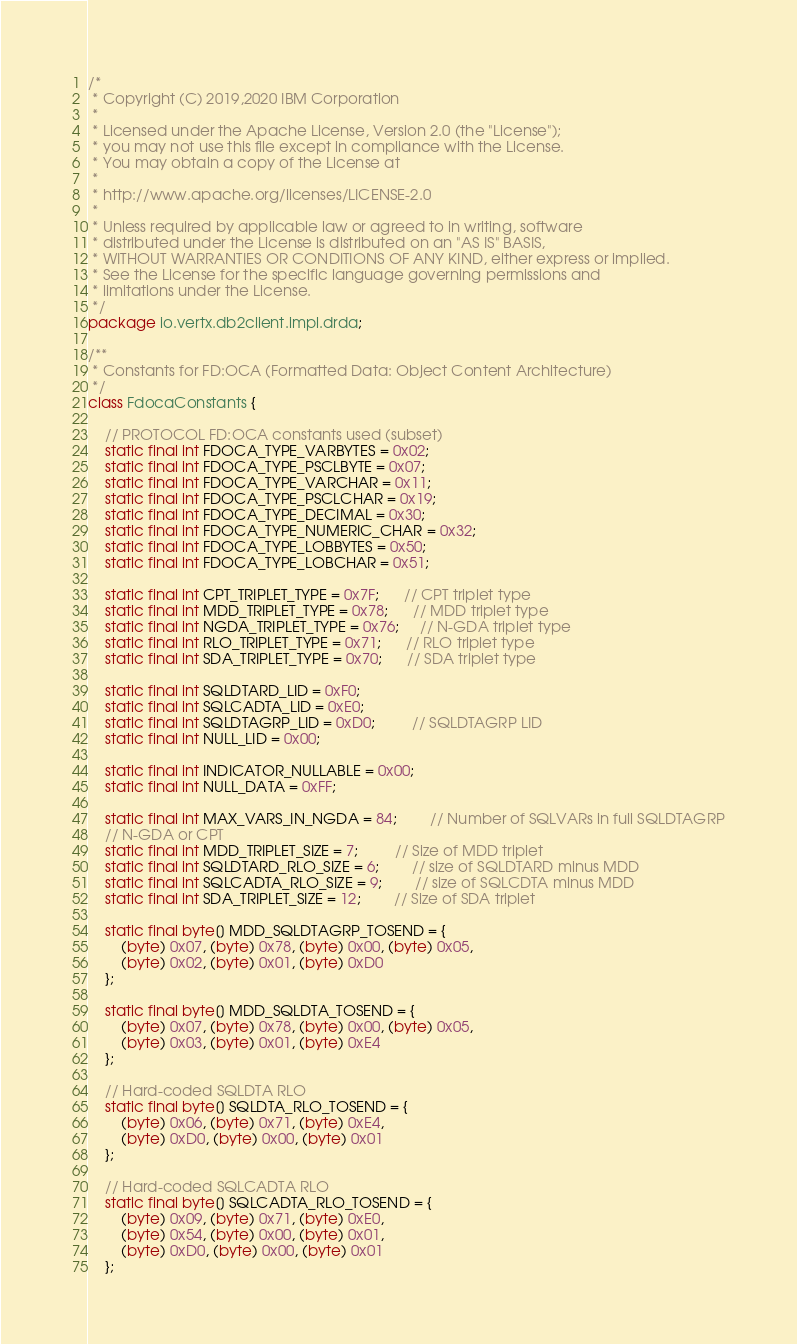<code> <loc_0><loc_0><loc_500><loc_500><_Java_>/*
 * Copyright (C) 2019,2020 IBM Corporation
 *
 * Licensed under the Apache License, Version 2.0 (the "License");
 * you may not use this file except in compliance with the License.
 * You may obtain a copy of the License at
 *
 * http://www.apache.org/licenses/LICENSE-2.0
 *
 * Unless required by applicable law or agreed to in writing, software
 * distributed under the License is distributed on an "AS IS" BASIS,
 * WITHOUT WARRANTIES OR CONDITIONS OF ANY KIND, either express or implied.
 * See the License for the specific language governing permissions and
 * limitations under the License.
 */
package io.vertx.db2client.impl.drda;

/**
 * Constants for FD:OCA (Formatted Data: Object Content Architecture) 
 */
class FdocaConstants {

    // PROTOCOL FD:OCA constants used (subset)
    static final int FDOCA_TYPE_VARBYTES = 0x02;
    static final int FDOCA_TYPE_PSCLBYTE = 0x07;
    static final int FDOCA_TYPE_VARCHAR = 0x11;
    static final int FDOCA_TYPE_PSCLCHAR = 0x19;
    static final int FDOCA_TYPE_DECIMAL = 0x30;
    static final int FDOCA_TYPE_NUMERIC_CHAR = 0x32;
    static final int FDOCA_TYPE_LOBBYTES = 0x50;
    static final int FDOCA_TYPE_LOBCHAR = 0x51;

    static final int CPT_TRIPLET_TYPE = 0x7F;      // CPT triplet type
    static final int MDD_TRIPLET_TYPE = 0x78;      // MDD triplet type
    static final int NGDA_TRIPLET_TYPE = 0x76;     // N-GDA triplet type
    static final int RLO_TRIPLET_TYPE = 0x71;      // RLO triplet type
    static final int SDA_TRIPLET_TYPE = 0x70;      // SDA triplet type

    static final int SQLDTARD_LID = 0xF0;
    static final int SQLCADTA_LID = 0xE0;
    static final int SQLDTAGRP_LID = 0xD0;         // SQLDTAGRP LID
    static final int NULL_LID = 0x00;

    static final int INDICATOR_NULLABLE = 0x00;
    static final int NULL_DATA = 0xFF;

    static final int MAX_VARS_IN_NGDA = 84;        // Number of SQLVARs in full SQLDTAGRP
    // N-GDA or CPT
    static final int MDD_TRIPLET_SIZE = 7;         // Size of MDD triplet
    static final int SQLDTARD_RLO_SIZE = 6;        // size of SQLDTARD minus MDD
    static final int SQLCADTA_RLO_SIZE = 9;        // size of SQLCDTA minus MDD
    static final int SDA_TRIPLET_SIZE = 12;        // Size of SDA triplet

    static final byte[] MDD_SQLDTAGRP_TOSEND = {
        (byte) 0x07, (byte) 0x78, (byte) 0x00, (byte) 0x05,
        (byte) 0x02, (byte) 0x01, (byte) 0xD0
    };

    static final byte[] MDD_SQLDTA_TOSEND = {
        (byte) 0x07, (byte) 0x78, (byte) 0x00, (byte) 0x05,
        (byte) 0x03, (byte) 0x01, (byte) 0xE4
    };

    // Hard-coded SQLDTA RLO
    static final byte[] SQLDTA_RLO_TOSEND = {
        (byte) 0x06, (byte) 0x71, (byte) 0xE4,
        (byte) 0xD0, (byte) 0x00, (byte) 0x01
    };

    // Hard-coded SQLCADTA RLO
    static final byte[] SQLCADTA_RLO_TOSEND = {
        (byte) 0x09, (byte) 0x71, (byte) 0xE0,
        (byte) 0x54, (byte) 0x00, (byte) 0x01,
        (byte) 0xD0, (byte) 0x00, (byte) 0x01
    };
</code> 